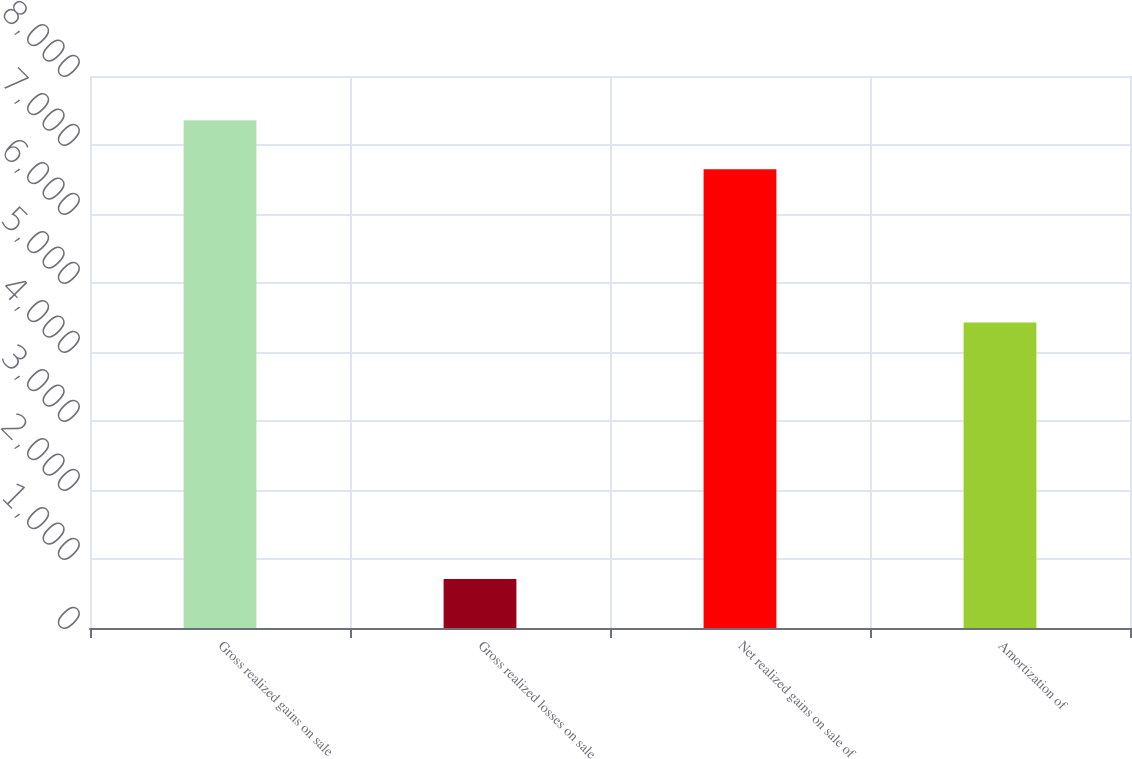Convert chart to OTSL. <chart><loc_0><loc_0><loc_500><loc_500><bar_chart><fcel>Gross realized gains on sale<fcel>Gross realized losses on sale<fcel>Net realized gains on sale of<fcel>Amortization of<nl><fcel>7360<fcel>710<fcel>6650<fcel>4427<nl></chart> 